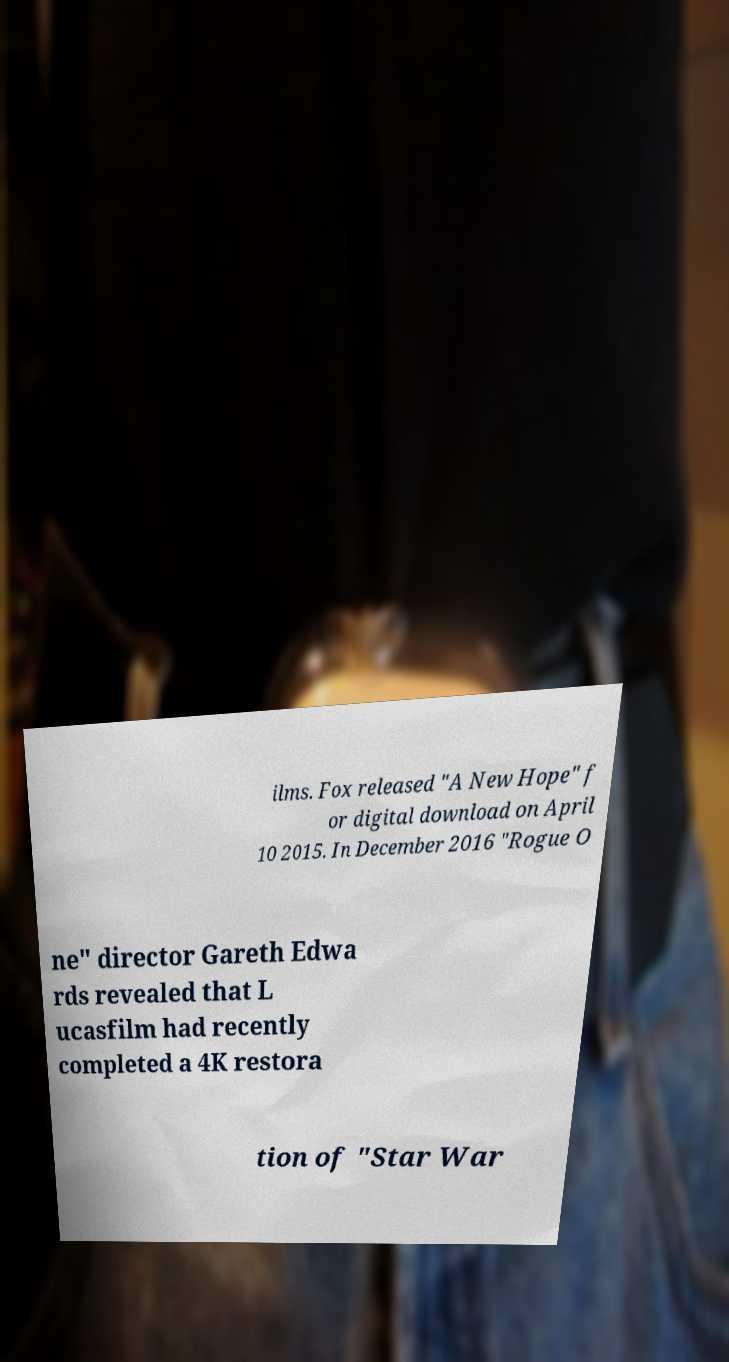Please read and relay the text visible in this image. What does it say? ilms. Fox released "A New Hope" f or digital download on April 10 2015. In December 2016 "Rogue O ne" director Gareth Edwa rds revealed that L ucasfilm had recently completed a 4K restora tion of "Star War 